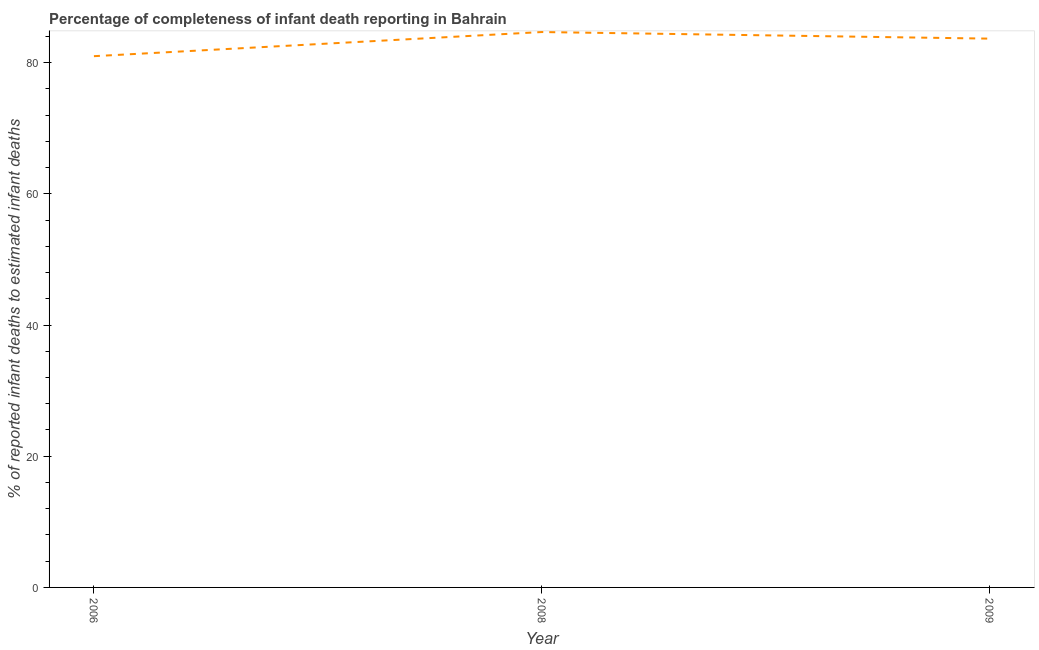What is the completeness of infant death reporting in 2006?
Keep it short and to the point. 80.99. Across all years, what is the maximum completeness of infant death reporting?
Offer a very short reply. 84.67. Across all years, what is the minimum completeness of infant death reporting?
Your answer should be very brief. 80.99. In which year was the completeness of infant death reporting minimum?
Give a very brief answer. 2006. What is the sum of the completeness of infant death reporting?
Your answer should be compact. 249.31. What is the difference between the completeness of infant death reporting in 2006 and 2008?
Give a very brief answer. -3.68. What is the average completeness of infant death reporting per year?
Give a very brief answer. 83.1. What is the median completeness of infant death reporting?
Offer a very short reply. 83.66. Do a majority of the years between 2009 and 2006 (inclusive) have completeness of infant death reporting greater than 56 %?
Keep it short and to the point. No. What is the ratio of the completeness of infant death reporting in 2006 to that in 2008?
Offer a terse response. 0.96. Is the difference between the completeness of infant death reporting in 2006 and 2009 greater than the difference between any two years?
Provide a succinct answer. No. What is the difference between the highest and the second highest completeness of infant death reporting?
Provide a succinct answer. 1.01. Is the sum of the completeness of infant death reporting in 2006 and 2008 greater than the maximum completeness of infant death reporting across all years?
Make the answer very short. Yes. What is the difference between the highest and the lowest completeness of infant death reporting?
Your answer should be compact. 3.68. In how many years, is the completeness of infant death reporting greater than the average completeness of infant death reporting taken over all years?
Give a very brief answer. 2. Does the completeness of infant death reporting monotonically increase over the years?
Offer a terse response. No. How many lines are there?
Your answer should be compact. 1. Does the graph contain any zero values?
Provide a short and direct response. No. What is the title of the graph?
Make the answer very short. Percentage of completeness of infant death reporting in Bahrain. What is the label or title of the Y-axis?
Provide a short and direct response. % of reported infant deaths to estimated infant deaths. What is the % of reported infant deaths to estimated infant deaths in 2006?
Provide a succinct answer. 80.99. What is the % of reported infant deaths to estimated infant deaths of 2008?
Give a very brief answer. 84.67. What is the % of reported infant deaths to estimated infant deaths of 2009?
Your response must be concise. 83.66. What is the difference between the % of reported infant deaths to estimated infant deaths in 2006 and 2008?
Make the answer very short. -3.68. What is the difference between the % of reported infant deaths to estimated infant deaths in 2006 and 2009?
Make the answer very short. -2.67. What is the difference between the % of reported infant deaths to estimated infant deaths in 2008 and 2009?
Provide a short and direct response. 1.01. 